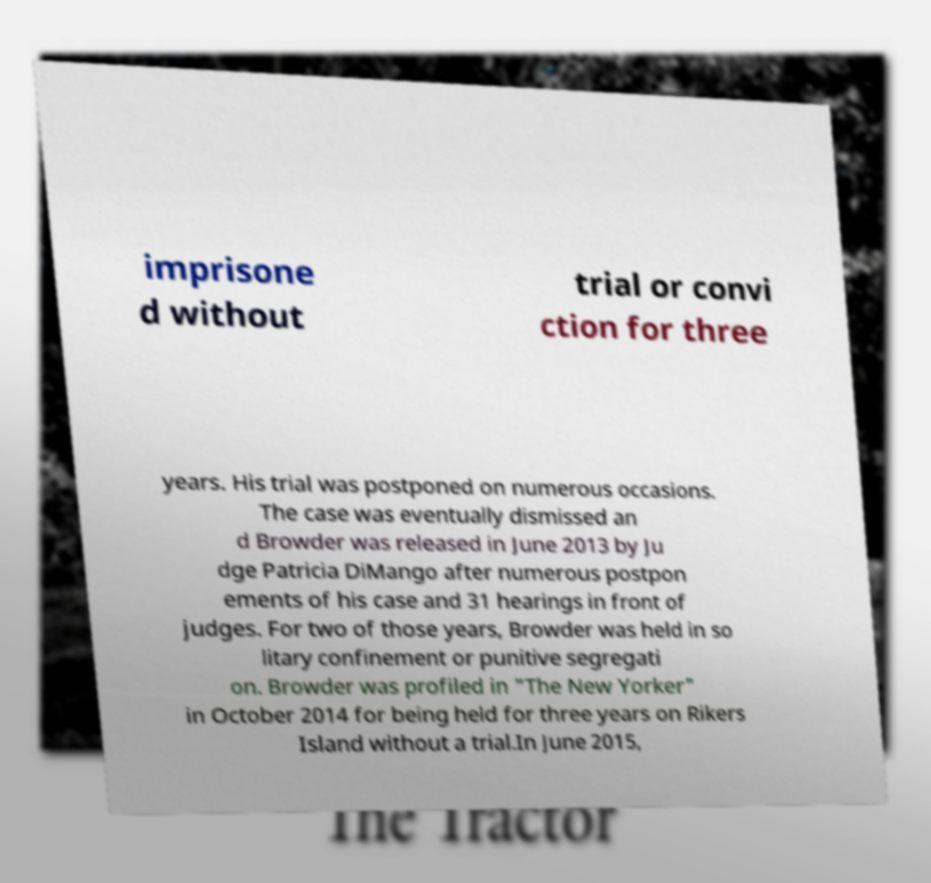For documentation purposes, I need the text within this image transcribed. Could you provide that? imprisone d without trial or convi ction for three years. His trial was postponed on numerous occasions. The case was eventually dismissed an d Browder was released in June 2013 by Ju dge Patricia DiMango after numerous postpon ements of his case and 31 hearings in front of judges. For two of those years, Browder was held in so litary confinement or punitive segregati on. Browder was profiled in "The New Yorker" in October 2014 for being held for three years on Rikers Island without a trial.In June 2015, 